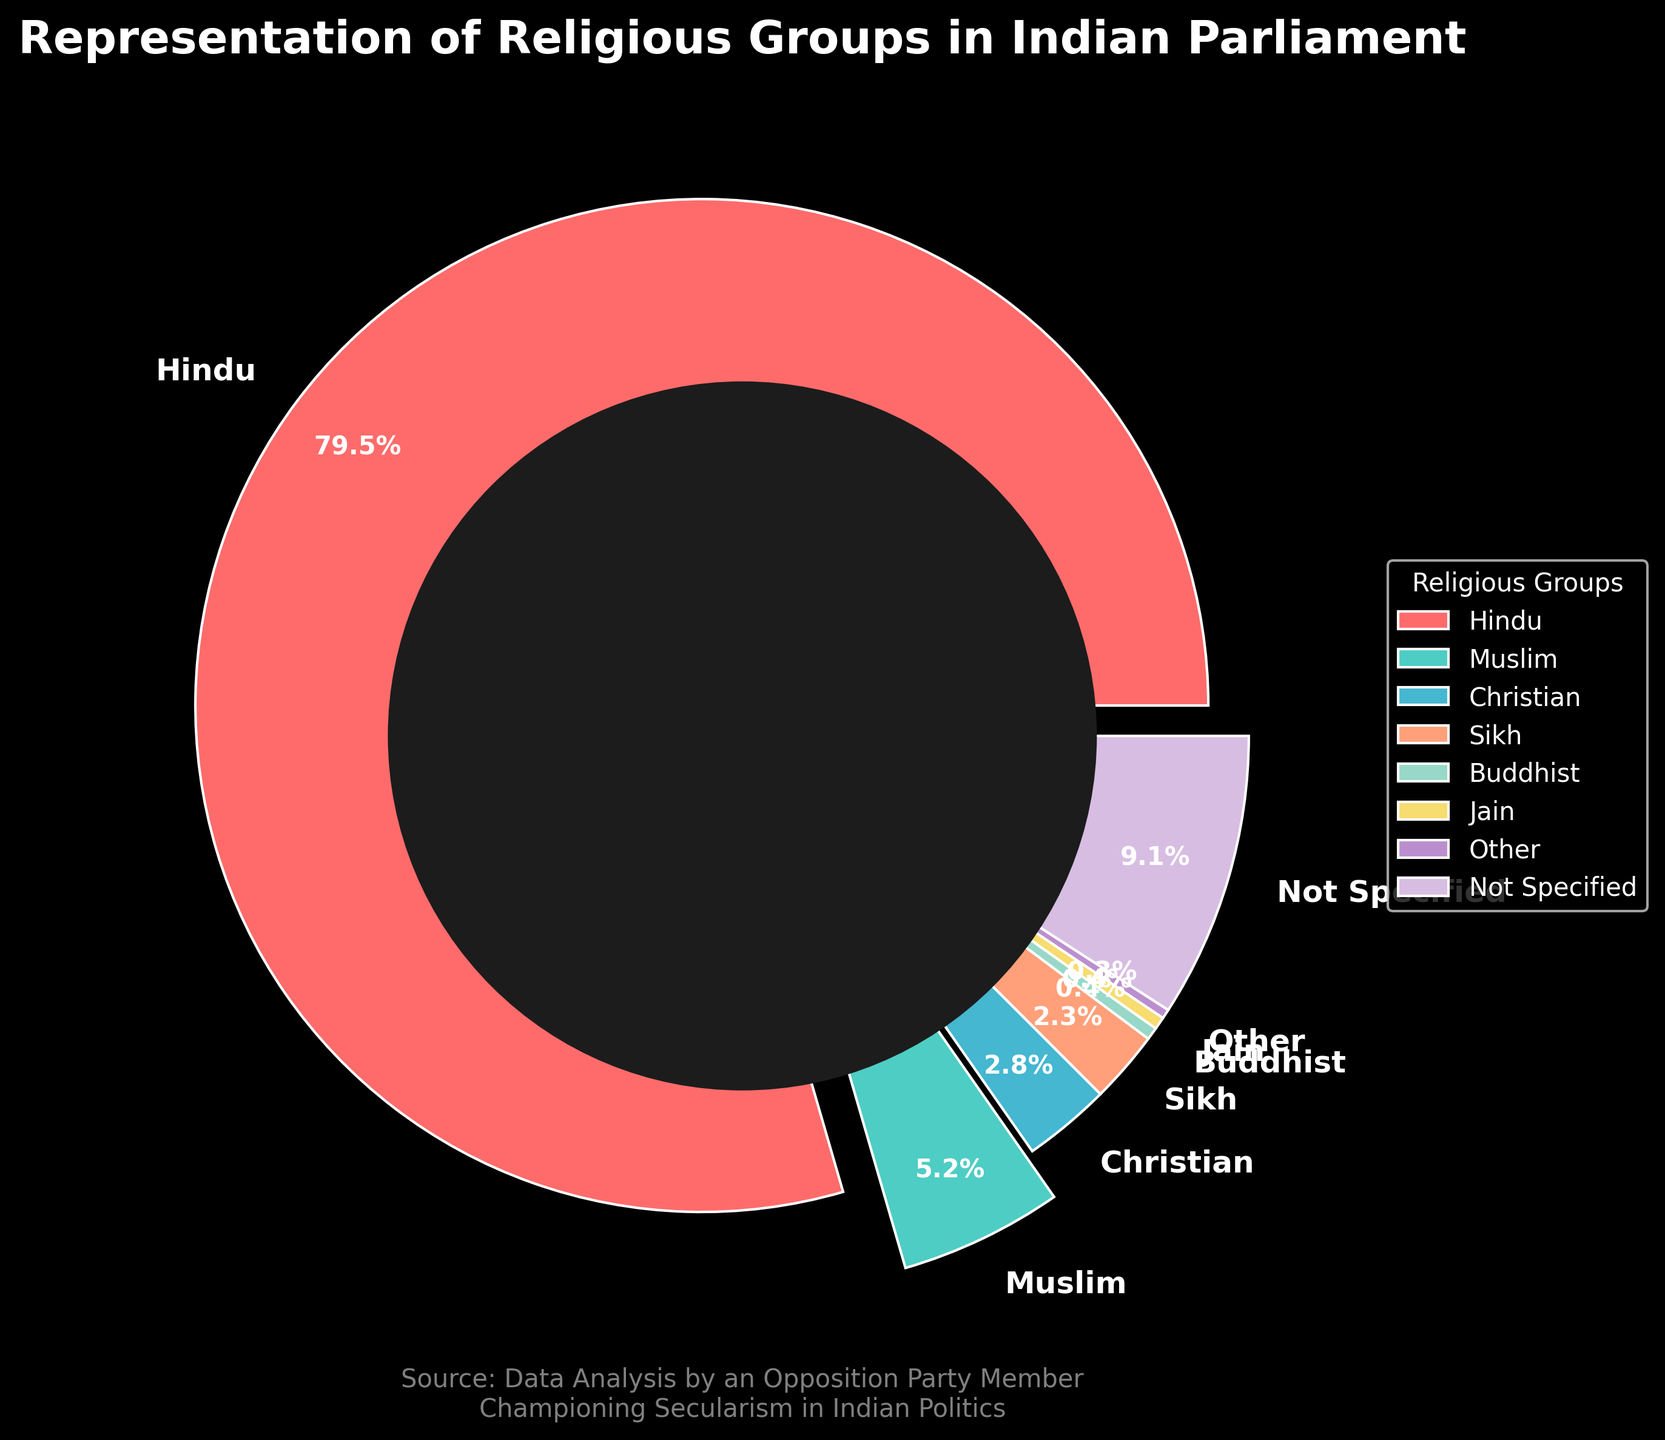Which religious group has the highest representation in the Indian Parliament? To determine which group has the highest representation, look at the wedge with the largest percentage. The Hindu group has a wedge labeled with 79.5%, which is the highest percentage.
Answer: Hindu What is the combined percentage of representation for Muslim and Christian groups? Identify the percentages for Muslim (5.2%) and Christian (2.8%) groups, then sum them up: 5.2 + 2.8 = 8.
Answer: 8% Which religious group is represented by the blue-colored wedge? Look at the blue-colored wedge in the pie chart and find its label, which is Muslim.
Answer: Muslim How does the representation of Sikhs compare with that of Buddhists and Jains combined? The representation for Sikhs is 2.3%. For Buddhists (0.4%) and Jains (0.4%), their combined percentage is 0.4 + 0.4 = 0.8%. Comparing these, 2.3% (Sikhs) is greater than 0.8% (Buddhists and Jains combined).
Answer: Greater What is the percentage difference between the representation of Hindus and Muslims? Identify the representation percentages for Hindus (79.5%) and Muslims (5.2%). The difference is 79.5 - 5.2 = 74.3.
Answer: 74.3% Which two religious groups have equal representation, and what is their percentage? Identify groups with the same percentage on the pie chart. Buddhists and Jains each have a representation of 0.4%.
Answer: Buddhists and Jains, 0.4% What percentage of the Indian Parliament is not specified in terms of religious group? Locate the section of the pie chart labeled 'Not Specified,' which has a percentage of 9.1%.
Answer: 9.1% Compare the combined representation of Sikh and other minority groups (Buddhist, Jain, and Other) to the representation of Christians. The combined representation of Sikh (2.3%), Buddhist (0.4%), Jain (0.4%), and Other (0.3%) is 2.3 + 0.4 + 0.4 + 0.3 = 3.4%. The representation of Christians is 2.8%. Comparing these, 3.4% (Sikh and other minority groups combined) is greater than 2.8% (Christians).
Answer: Greater What is the total percentage of representation for groups other than Hindu? Subtract the Hindu percentage (79.5%) from 100% to find the total percentage for all other groups: 100 - 79.5 = 20.5%.
Answer: 20.5% Which religious group appears to have the smallest wedge in the pie chart, and what is the percentage? Look for the smallest wedge in the pie chart, which is labeled 'Other' with a percentage of 0.3%.
Answer: Other, 0.3% 